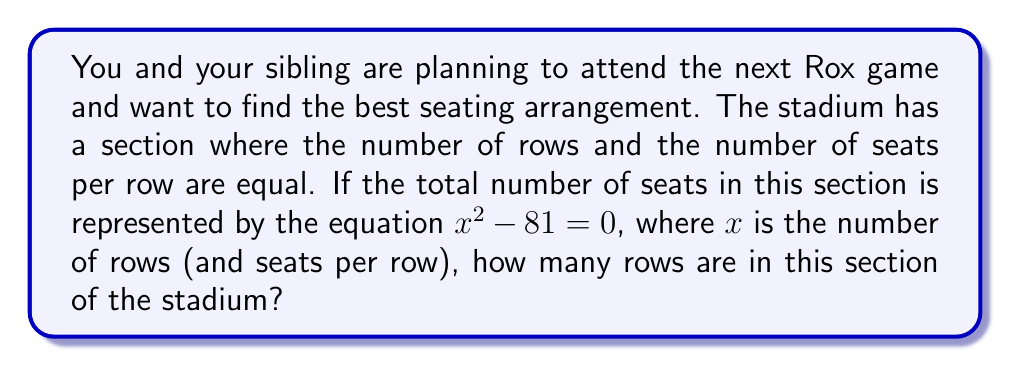Solve this math problem. To solve this problem, we need to factor the polynomial equation and solve for $x$. Let's approach this step-by-step:

1) We start with the equation: $x^2 - 81 = 0$

2) This is a quadratic equation in the form $a^2 - b^2 = 0$, which is a difference of squares.

3) The difference of squares formula is: $a^2 - b^2 = (a+b)(a-b)$

4) In our case, $a^2 = x^2$ and $b^2 = 81$

5) We can rewrite our equation as: $(x+9)(x-9) = 0$

6) For this equation to be true, either $(x+9) = 0$ or $(x-9) = 0$

7) Solving these:
   $x+9 = 0$ gives $x = -9$
   $x-9 = 0$ gives $x = 9$

8) Since we're dealing with the number of rows in a stadium, we can discard the negative solution.

Therefore, there are 9 rows in this section of the stadium.
Answer: 9 rows 